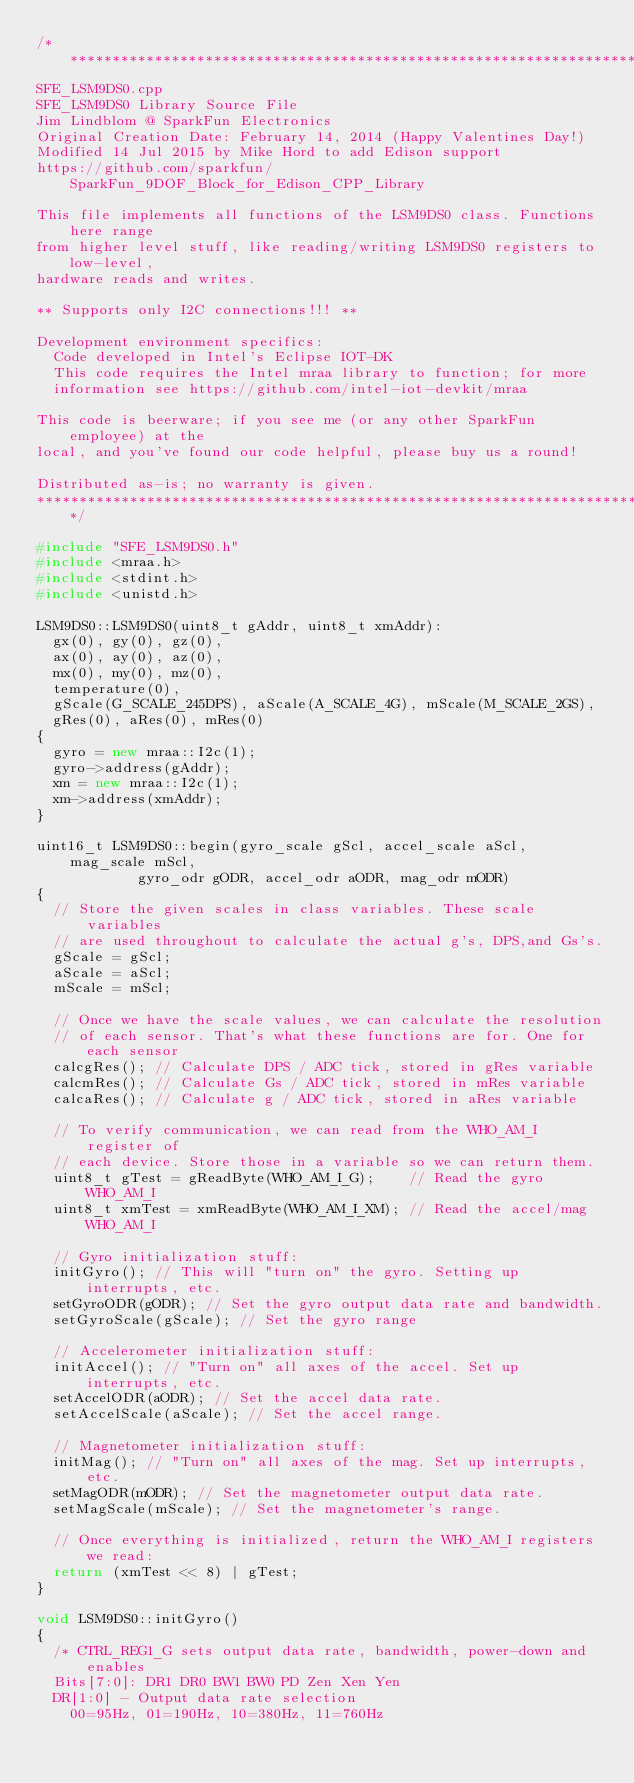<code> <loc_0><loc_0><loc_500><loc_500><_C++_>/******************************************************************************
SFE_LSM9DS0.cpp
SFE_LSM9DS0 Library Source File
Jim Lindblom @ SparkFun Electronics
Original Creation Date: February 14, 2014 (Happy Valentines Day!)
Modified 14 Jul 2015 by Mike Hord to add Edison support
https://github.com/sparkfun/SparkFun_9DOF_Block_for_Edison_CPP_Library

This file implements all functions of the LSM9DS0 class. Functions here range
from higher level stuff, like reading/writing LSM9DS0 registers to low-level,
hardware reads and writes.

** Supports only I2C connections!!! **

Development environment specifics:
  Code developed in Intel's Eclipse IOT-DK
  This code requires the Intel mraa library to function; for more
  information see https://github.com/intel-iot-devkit/mraa

This code is beerware; if you see me (or any other SparkFun employee) at the
local, and you've found our code helpful, please buy us a round!

Distributed as-is; no warranty is given.
******************************************************************************/

#include "SFE_LSM9DS0.h"
#include <mraa.h>
#include <stdint.h>
#include <unistd.h>

LSM9DS0::LSM9DS0(uint8_t gAddr, uint8_t xmAddr):
  gx(0), gy(0), gz(0),
  ax(0), ay(0), az(0),
  mx(0), my(0), mz(0),
  temperature(0),
  gScale(G_SCALE_245DPS), aScale(A_SCALE_4G), mScale(M_SCALE_2GS),
  gRes(0), aRes(0), mRes(0)
{
  gyro = new mraa::I2c(1);
  gyro->address(gAddr);
  xm = new mraa::I2c(1);
  xm->address(xmAddr);
}

uint16_t LSM9DS0::begin(gyro_scale gScl, accel_scale aScl, mag_scale mScl, 
						gyro_odr gODR, accel_odr aODR, mag_odr mODR)
{
	// Store the given scales in class variables. These scale variables
	// are used throughout to calculate the actual g's, DPS,and Gs's.
	gScale = gScl;
	aScale = aScl;
	mScale = mScl;
	
	// Once we have the scale values, we can calculate the resolution
	// of each sensor. That's what these functions are for. One for each sensor
	calcgRes(); // Calculate DPS / ADC tick, stored in gRes variable
	calcmRes(); // Calculate Gs / ADC tick, stored in mRes variable
	calcaRes(); // Calculate g / ADC tick, stored in aRes variable
	
	// To verify communication, we can read from the WHO_AM_I register of
	// each device. Store those in a variable so we can return them.
	uint8_t gTest = gReadByte(WHO_AM_I_G);		// Read the gyro WHO_AM_I
	uint8_t xmTest = xmReadByte(WHO_AM_I_XM);	// Read the accel/mag WHO_AM_I
	
	// Gyro initialization stuff:
	initGyro();	// This will "turn on" the gyro. Setting up interrupts, etc.
	setGyroODR(gODR); // Set the gyro output data rate and bandwidth.
	setGyroScale(gScale); // Set the gyro range
	
	// Accelerometer initialization stuff:
	initAccel(); // "Turn on" all axes of the accel. Set up interrupts, etc.
	setAccelODR(aODR); // Set the accel data rate.
	setAccelScale(aScale); // Set the accel range.
	
	// Magnetometer initialization stuff:
	initMag(); // "Turn on" all axes of the mag. Set up interrupts, etc.
	setMagODR(mODR); // Set the magnetometer output data rate.
	setMagScale(mScale); // Set the magnetometer's range.
	
	// Once everything is initialized, return the WHO_AM_I registers we read:
	return (xmTest << 8) | gTest;
}

void LSM9DS0::initGyro()
{
	/* CTRL_REG1_G sets output data rate, bandwidth, power-down and enables
	Bits[7:0]: DR1 DR0 BW1 BW0 PD Zen Xen Yen
	DR[1:0] - Output data rate selection
		00=95Hz, 01=190Hz, 10=380Hz, 11=760Hz</code> 